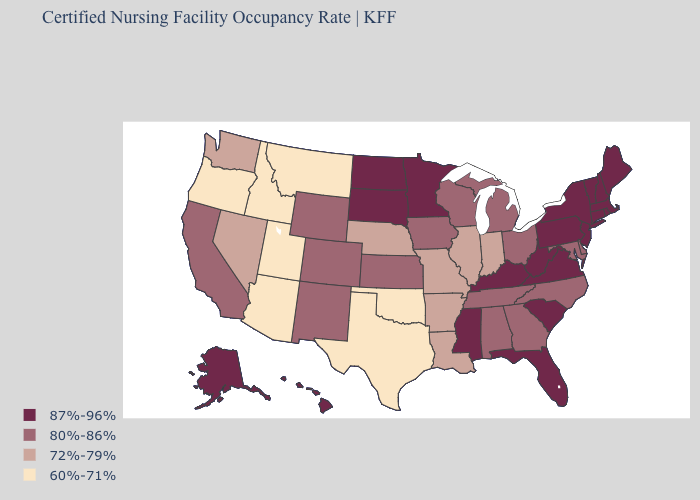How many symbols are there in the legend?
Give a very brief answer. 4. What is the lowest value in states that border Mississippi?
Concise answer only. 72%-79%. Name the states that have a value in the range 72%-79%?
Concise answer only. Arkansas, Illinois, Indiana, Louisiana, Missouri, Nebraska, Nevada, Washington. Among the states that border Nebraska , does Missouri have the lowest value?
Short answer required. Yes. Does the map have missing data?
Quick response, please. No. What is the value of Texas?
Concise answer only. 60%-71%. What is the value of Pennsylvania?
Be succinct. 87%-96%. Which states have the lowest value in the West?
Be succinct. Arizona, Idaho, Montana, Oregon, Utah. Does Virginia have the highest value in the USA?
Answer briefly. Yes. What is the value of Maine?
Be succinct. 87%-96%. Name the states that have a value in the range 80%-86%?
Concise answer only. Alabama, California, Colorado, Delaware, Georgia, Iowa, Kansas, Maryland, Michigan, New Mexico, North Carolina, Ohio, Tennessee, Wisconsin, Wyoming. What is the value of Idaho?
Be succinct. 60%-71%. What is the value of Hawaii?
Quick response, please. 87%-96%. What is the highest value in states that border Alabama?
Concise answer only. 87%-96%. Does the map have missing data?
Be succinct. No. 